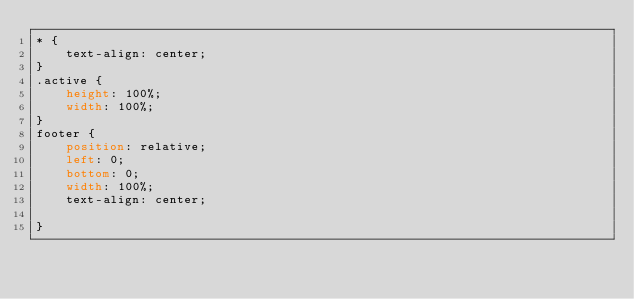<code> <loc_0><loc_0><loc_500><loc_500><_CSS_>* {
    text-align: center;
}
.active {
    height: 100%;
    width: 100%;
}
footer {
    position: relative;
    left: 0;
    bottom: 0;
    width: 100%;
    text-align: center;
  
}</code> 